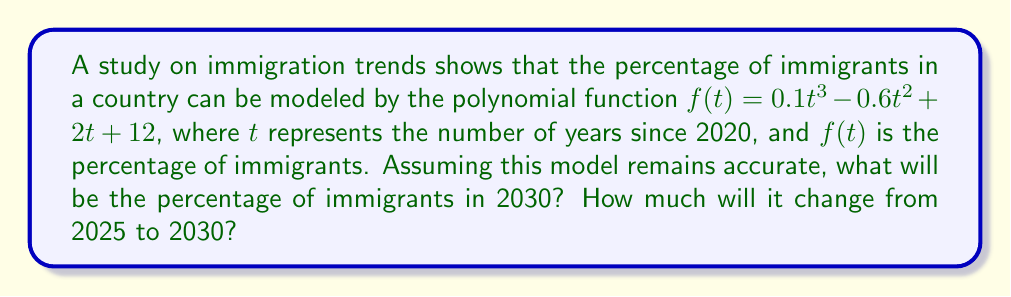Can you answer this question? Let's approach this step-by-step:

1) First, we need to find $f(5)$ and $f(10)$, as 2025 is 5 years after 2020, and 2030 is 10 years after 2020.

2) For 2025 (t = 5):
   $f(5) = 0.1(5)^3 - 0.6(5)^2 + 2(5) + 12$
   $= 0.1(125) - 0.6(25) + 10 + 12$
   $= 12.5 - 15 + 10 + 12$
   $= 19.5$

3) For 2030 (t = 10):
   $f(10) = 0.1(10)^3 - 0.6(10)^2 + 2(10) + 12$
   $= 0.1(1000) - 0.6(100) + 20 + 12$
   $= 100 - 60 + 20 + 12$
   $= 72$

4) The percentage of immigrants in 2030 will be 72%.

5) To find the change from 2025 to 2030:
   Change = $f(10) - f(5) = 72 - 19.5 = 52.5$

Therefore, the percentage of immigrants will increase by 52.5 percentage points from 2025 to 2030.
Answer: 72%; 52.5 percentage points 